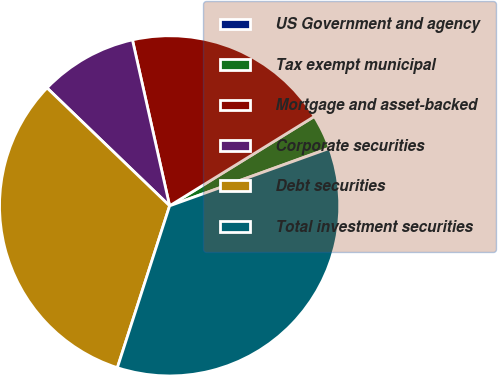<chart> <loc_0><loc_0><loc_500><loc_500><pie_chart><fcel>US Government and agency<fcel>Tax exempt municipal<fcel>Mortgage and asset-backed<fcel>Corporate securities<fcel>Debt securities<fcel>Total investment securities<nl><fcel>0.03%<fcel>3.28%<fcel>19.7%<fcel>9.3%<fcel>32.22%<fcel>35.47%<nl></chart> 